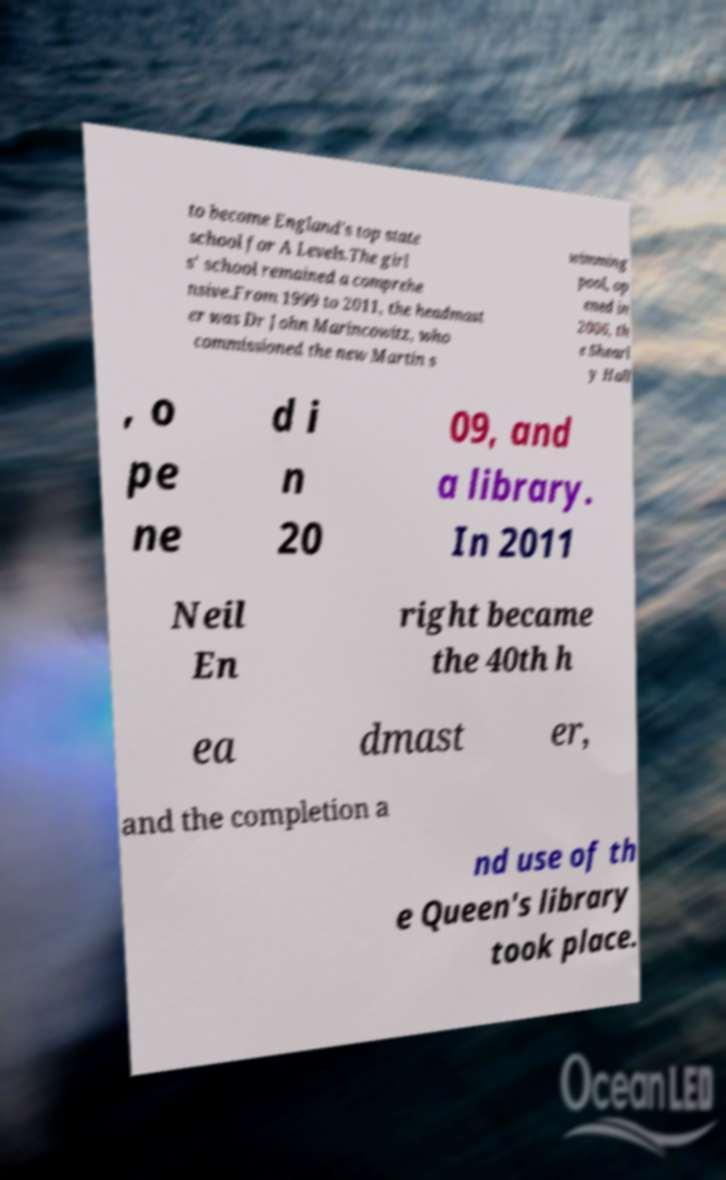Please identify and transcribe the text found in this image. to become England's top state school for A Levels.The girl s' school remained a comprehe nsive.From 1999 to 2011, the headmast er was Dr John Marincowitz, who commissioned the new Martin s wimming pool, op ened in 2006, th e Shearl y Hall , o pe ne d i n 20 09, and a library. In 2011 Neil En right became the 40th h ea dmast er, and the completion a nd use of th e Queen's library took place. 